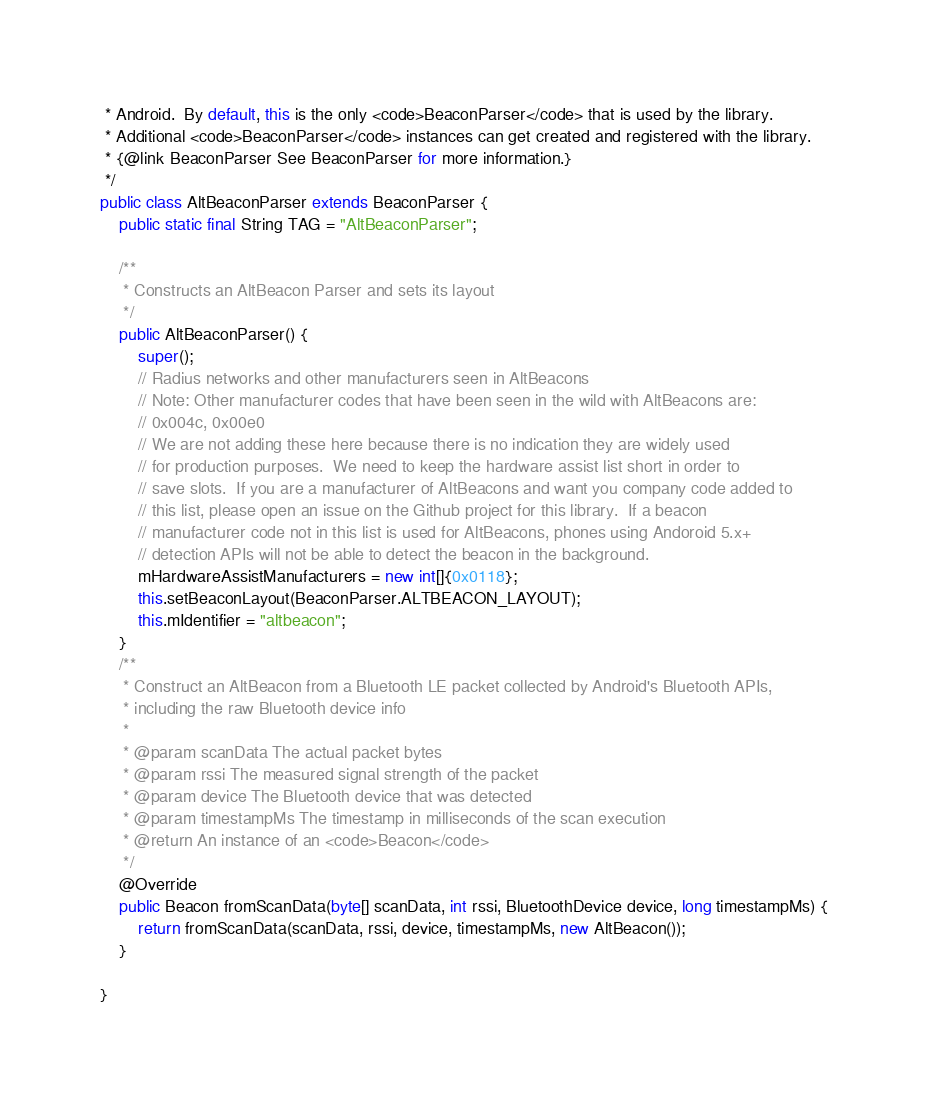<code> <loc_0><loc_0><loc_500><loc_500><_Java_> * Android.  By default, this is the only <code>BeaconParser</code> that is used by the library.
 * Additional <code>BeaconParser</code> instances can get created and registered with the library.
 * {@link BeaconParser See BeaconParser for more information.}
 */
public class AltBeaconParser extends BeaconParser {
    public static final String TAG = "AltBeaconParser";

    /**
     * Constructs an AltBeacon Parser and sets its layout
     */
    public AltBeaconParser() {
        super();
        // Radius networks and other manufacturers seen in AltBeacons
        // Note: Other manufacturer codes that have been seen in the wild with AltBeacons are:
        // 0x004c, 0x00e0
        // We are not adding these here because there is no indication they are widely used
        // for production purposes.  We need to keep the hardware assist list short in order to
        // save slots.  If you are a manufacturer of AltBeacons and want you company code added to
        // this list, please open an issue on the Github project for this library.  If a beacon
        // manufacturer code not in this list is used for AltBeacons, phones using Andoroid 5.x+
        // detection APIs will not be able to detect the beacon in the background.
        mHardwareAssistManufacturers = new int[]{0x0118};
        this.setBeaconLayout(BeaconParser.ALTBEACON_LAYOUT);
        this.mIdentifier = "altbeacon";
    }
    /**
     * Construct an AltBeacon from a Bluetooth LE packet collected by Android's Bluetooth APIs,
     * including the raw Bluetooth device info
     *
     * @param scanData The actual packet bytes
     * @param rssi The measured signal strength of the packet
     * @param device The Bluetooth device that was detected
     * @param timestampMs The timestamp in milliseconds of the scan execution
     * @return An instance of an <code>Beacon</code>
     */
    @Override
    public Beacon fromScanData(byte[] scanData, int rssi, BluetoothDevice device, long timestampMs) {
        return fromScanData(scanData, rssi, device, timestampMs, new AltBeacon());
    }

}
</code> 